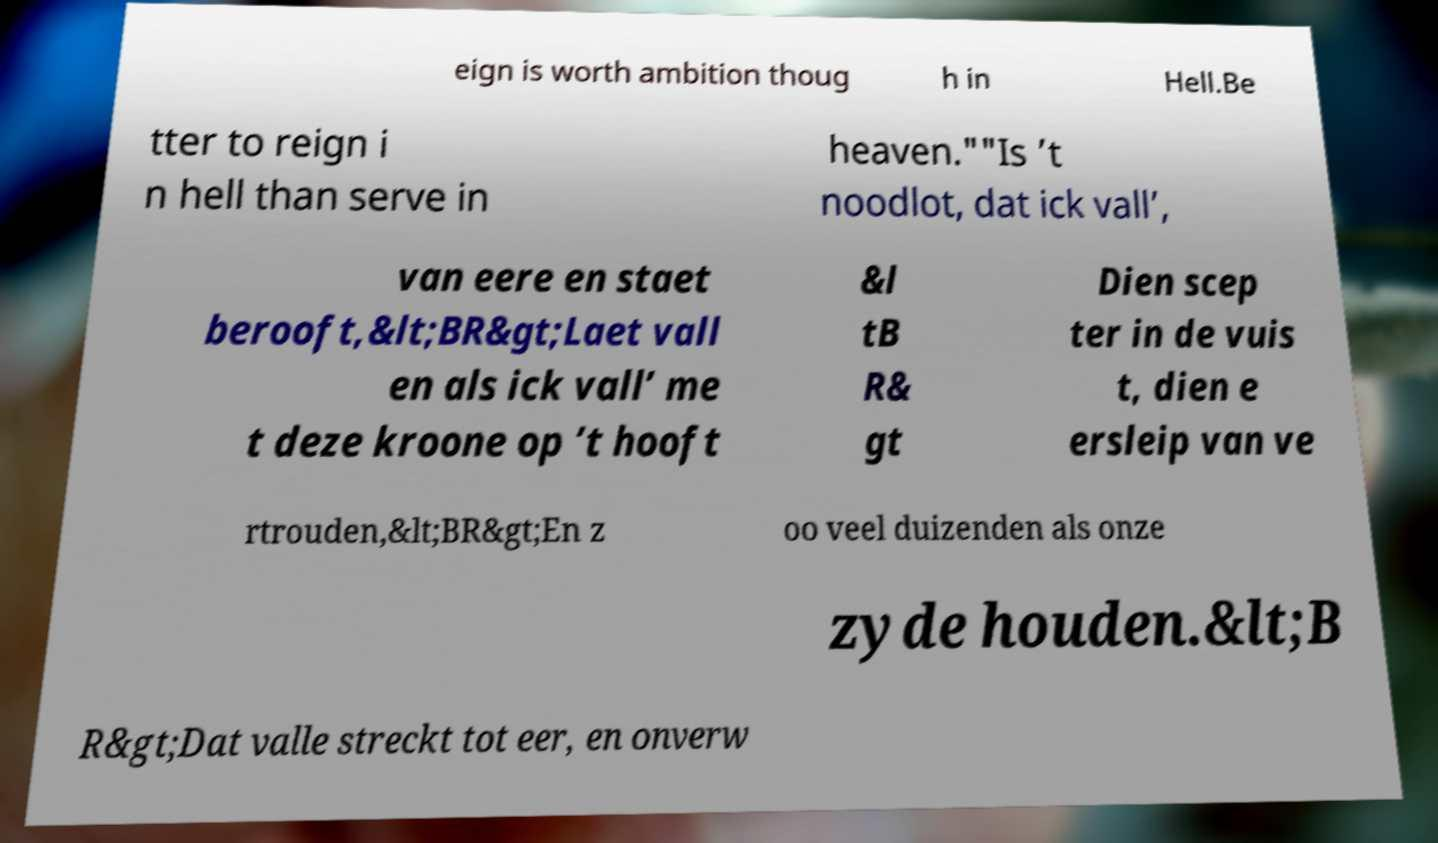I need the written content from this picture converted into text. Can you do that? eign is worth ambition thoug h in Hell.Be tter to reign i n hell than serve in heaven.""Is ’t noodlot, dat ick vall’, van eere en staet berooft,&lt;BR&gt;Laet vall en als ick vall’ me t deze kroone op ’t hooft &l tB R& gt Dien scep ter in de vuis t, dien e ersleip van ve rtrouden,&lt;BR&gt;En z oo veel duizenden als onze zyde houden.&lt;B R&gt;Dat valle streckt tot eer, en onverw 